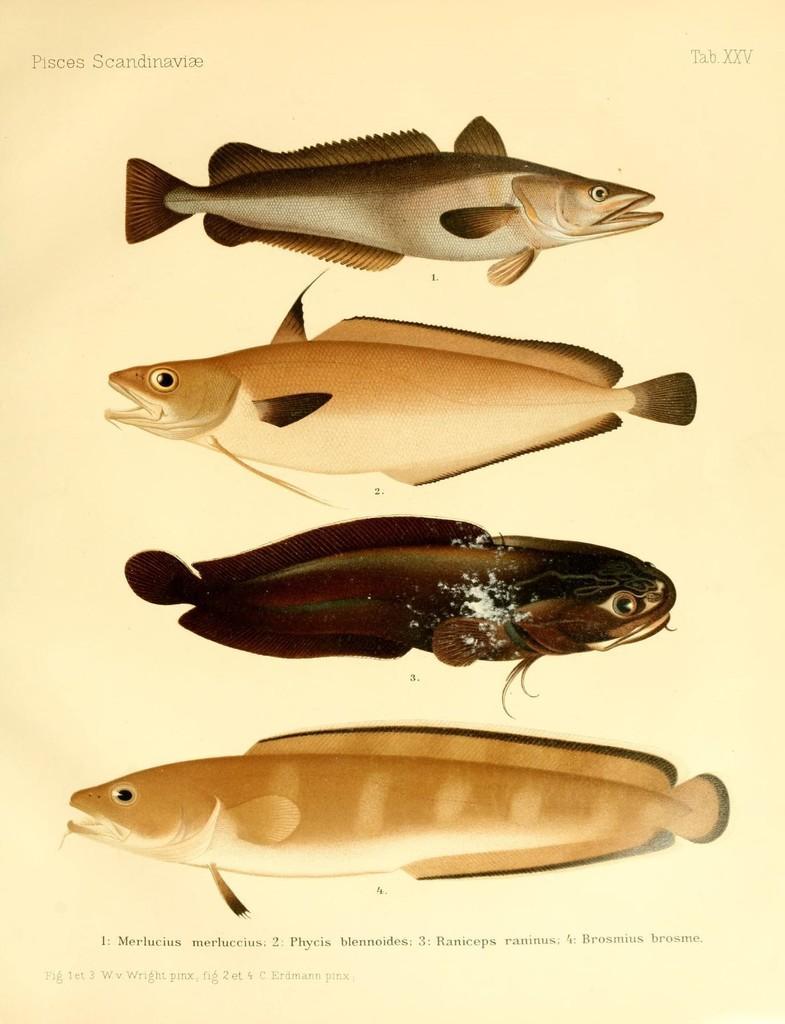In one or two sentences, can you explain what this image depicts? In this image we can see a paper. On that there are different types of fishes. Also there are some text on the paper. 